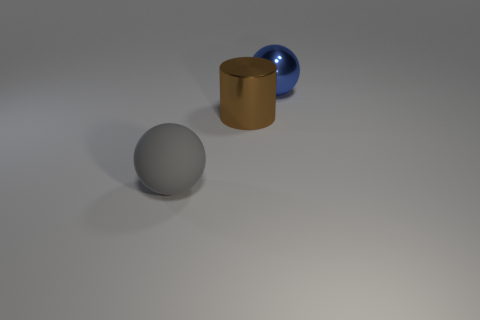What is the size of the object that is both in front of the blue ball and right of the large gray sphere?
Ensure brevity in your answer.  Large. Is the number of large purple rubber balls less than the number of big brown metallic objects?
Provide a succinct answer. Yes. How big is the ball that is to the right of the gray rubber ball?
Keep it short and to the point. Large. The large object that is both left of the large blue metal ball and right of the gray thing has what shape?
Your answer should be compact. Cylinder. There is another object that is the same shape as the large rubber object; what is its size?
Give a very brief answer. Large. How many large gray things are the same material as the large brown cylinder?
Make the answer very short. 0. There is a matte ball; is it the same color as the metallic thing that is behind the brown metal thing?
Your answer should be compact. No. Are there more balls than purple shiny spheres?
Give a very brief answer. Yes. What color is the big metallic cylinder?
Give a very brief answer. Brown. There is a sphere right of the matte thing; does it have the same color as the big metallic cylinder?
Keep it short and to the point. No. 